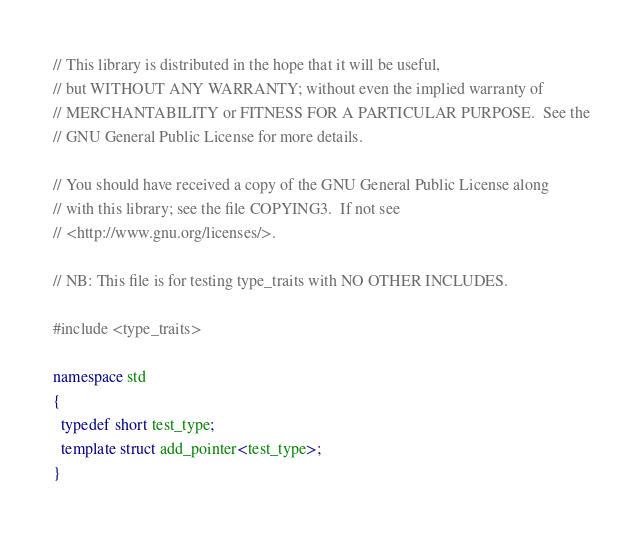<code> <loc_0><loc_0><loc_500><loc_500><_C++_>
// This library is distributed in the hope that it will be useful,
// but WITHOUT ANY WARRANTY; without even the implied warranty of
// MERCHANTABILITY or FITNESS FOR A PARTICULAR PURPOSE.  See the
// GNU General Public License for more details.

// You should have received a copy of the GNU General Public License along
// with this library; see the file COPYING3.  If not see
// <http://www.gnu.org/licenses/>.

// NB: This file is for testing type_traits with NO OTHER INCLUDES.

#include <type_traits>

namespace std
{
  typedef short test_type;
  template struct add_pointer<test_type>;
}
</code> 